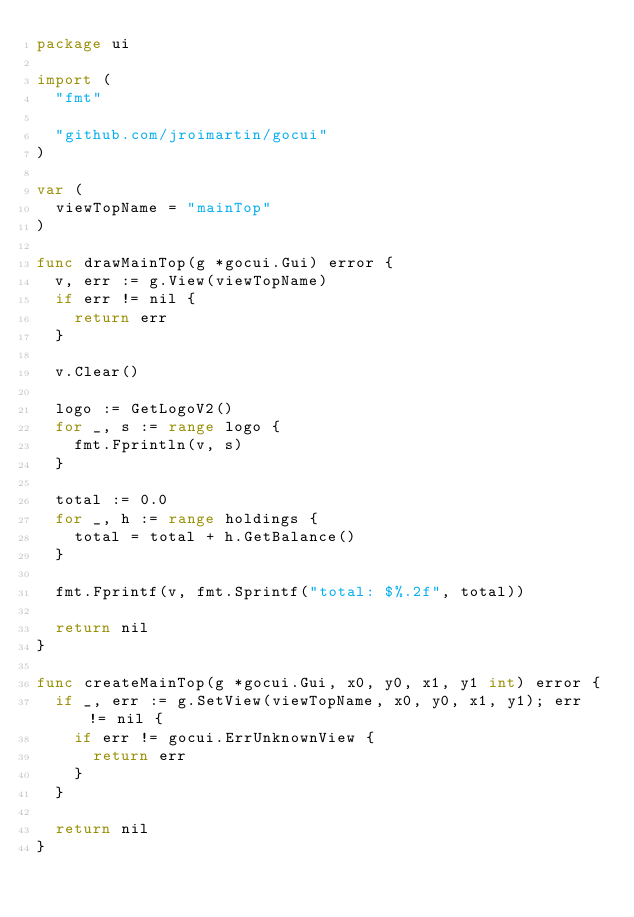Convert code to text. <code><loc_0><loc_0><loc_500><loc_500><_Go_>package ui

import (
	"fmt"

	"github.com/jroimartin/gocui"
)

var (
	viewTopName = "mainTop"
)

func drawMainTop(g *gocui.Gui) error {
	v, err := g.View(viewTopName)
	if err != nil {
		return err
	}

	v.Clear()

	logo := GetLogoV2()
	for _, s := range logo {
		fmt.Fprintln(v, s)
	}

	total := 0.0
	for _, h := range holdings {
		total = total + h.GetBalance()
	}

	fmt.Fprintf(v, fmt.Sprintf("total: $%.2f", total))

	return nil
}

func createMainTop(g *gocui.Gui, x0, y0, x1, y1 int) error {
	if _, err := g.SetView(viewTopName, x0, y0, x1, y1); err != nil {
		if err != gocui.ErrUnknownView {
			return err
		}
	}

	return nil
}
</code> 